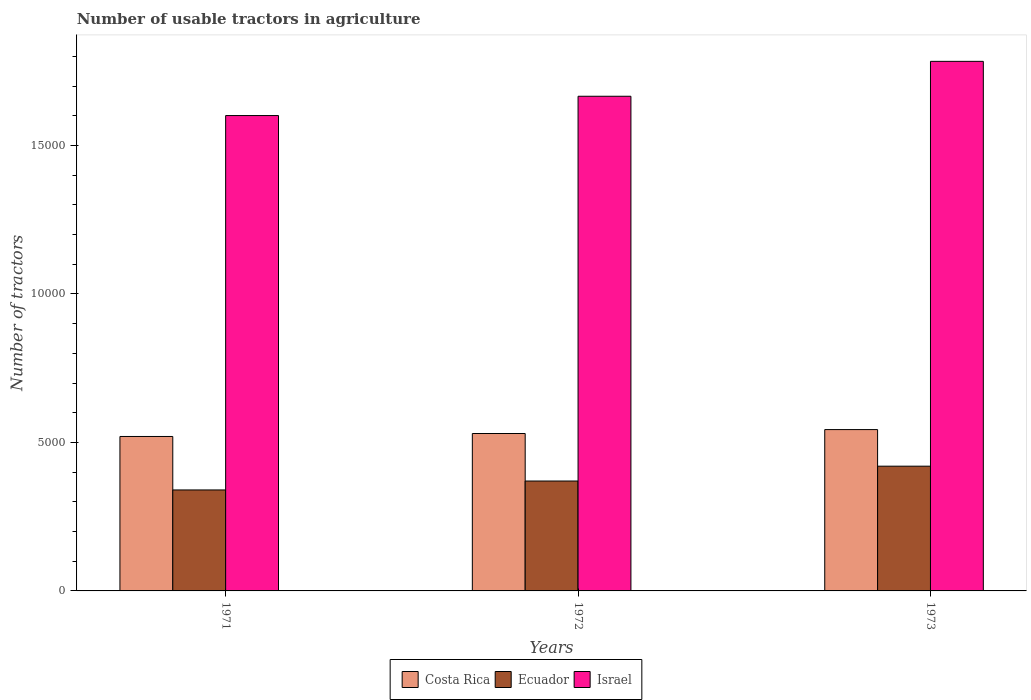How many different coloured bars are there?
Offer a terse response. 3. Are the number of bars on each tick of the X-axis equal?
Provide a succinct answer. Yes. What is the label of the 1st group of bars from the left?
Your answer should be very brief. 1971. In how many cases, is the number of bars for a given year not equal to the number of legend labels?
Give a very brief answer. 0. What is the number of usable tractors in agriculture in Costa Rica in 1972?
Make the answer very short. 5300. Across all years, what is the maximum number of usable tractors in agriculture in Israel?
Make the answer very short. 1.78e+04. Across all years, what is the minimum number of usable tractors in agriculture in Ecuador?
Ensure brevity in your answer.  3400. What is the total number of usable tractors in agriculture in Israel in the graph?
Offer a terse response. 5.05e+04. What is the difference between the number of usable tractors in agriculture in Israel in 1971 and that in 1973?
Your response must be concise. -1825. What is the difference between the number of usable tractors in agriculture in Israel in 1973 and the number of usable tractors in agriculture in Ecuador in 1972?
Give a very brief answer. 1.41e+04. What is the average number of usable tractors in agriculture in Ecuador per year?
Your answer should be very brief. 3766.67. In the year 1973, what is the difference between the number of usable tractors in agriculture in Costa Rica and number of usable tractors in agriculture in Ecuador?
Provide a succinct answer. 1232. What is the ratio of the number of usable tractors in agriculture in Costa Rica in 1972 to that in 1973?
Your response must be concise. 0.98. Is the difference between the number of usable tractors in agriculture in Costa Rica in 1971 and 1973 greater than the difference between the number of usable tractors in agriculture in Ecuador in 1971 and 1973?
Provide a succinct answer. Yes. What is the difference between the highest and the second highest number of usable tractors in agriculture in Israel?
Give a very brief answer. 1175. What is the difference between the highest and the lowest number of usable tractors in agriculture in Costa Rica?
Ensure brevity in your answer.  232. What does the 2nd bar from the left in 1972 represents?
Your response must be concise. Ecuador. Are all the bars in the graph horizontal?
Provide a succinct answer. No. Where does the legend appear in the graph?
Offer a terse response. Bottom center. How are the legend labels stacked?
Make the answer very short. Horizontal. What is the title of the graph?
Your answer should be very brief. Number of usable tractors in agriculture. Does "Singapore" appear as one of the legend labels in the graph?
Your response must be concise. No. What is the label or title of the X-axis?
Offer a terse response. Years. What is the label or title of the Y-axis?
Make the answer very short. Number of tractors. What is the Number of tractors in Costa Rica in 1971?
Ensure brevity in your answer.  5200. What is the Number of tractors of Ecuador in 1971?
Offer a terse response. 3400. What is the Number of tractors in Israel in 1971?
Offer a terse response. 1.60e+04. What is the Number of tractors in Costa Rica in 1972?
Your answer should be very brief. 5300. What is the Number of tractors of Ecuador in 1972?
Your answer should be very brief. 3700. What is the Number of tractors of Israel in 1972?
Offer a terse response. 1.67e+04. What is the Number of tractors of Costa Rica in 1973?
Provide a short and direct response. 5432. What is the Number of tractors in Ecuador in 1973?
Offer a very short reply. 4200. What is the Number of tractors in Israel in 1973?
Offer a very short reply. 1.78e+04. Across all years, what is the maximum Number of tractors in Costa Rica?
Keep it short and to the point. 5432. Across all years, what is the maximum Number of tractors of Ecuador?
Give a very brief answer. 4200. Across all years, what is the maximum Number of tractors in Israel?
Your response must be concise. 1.78e+04. Across all years, what is the minimum Number of tractors in Costa Rica?
Ensure brevity in your answer.  5200. Across all years, what is the minimum Number of tractors in Ecuador?
Provide a short and direct response. 3400. Across all years, what is the minimum Number of tractors in Israel?
Your response must be concise. 1.60e+04. What is the total Number of tractors of Costa Rica in the graph?
Ensure brevity in your answer.  1.59e+04. What is the total Number of tractors in Ecuador in the graph?
Provide a succinct answer. 1.13e+04. What is the total Number of tractors in Israel in the graph?
Offer a terse response. 5.05e+04. What is the difference between the Number of tractors of Costa Rica in 1971 and that in 1972?
Ensure brevity in your answer.  -100. What is the difference between the Number of tractors of Ecuador in 1971 and that in 1972?
Your response must be concise. -300. What is the difference between the Number of tractors in Israel in 1971 and that in 1972?
Your answer should be compact. -650. What is the difference between the Number of tractors in Costa Rica in 1971 and that in 1973?
Ensure brevity in your answer.  -232. What is the difference between the Number of tractors of Ecuador in 1971 and that in 1973?
Make the answer very short. -800. What is the difference between the Number of tractors of Israel in 1971 and that in 1973?
Your answer should be compact. -1825. What is the difference between the Number of tractors of Costa Rica in 1972 and that in 1973?
Your answer should be very brief. -132. What is the difference between the Number of tractors in Ecuador in 1972 and that in 1973?
Your response must be concise. -500. What is the difference between the Number of tractors in Israel in 1972 and that in 1973?
Your answer should be very brief. -1175. What is the difference between the Number of tractors of Costa Rica in 1971 and the Number of tractors of Ecuador in 1972?
Ensure brevity in your answer.  1500. What is the difference between the Number of tractors in Costa Rica in 1971 and the Number of tractors in Israel in 1972?
Your answer should be very brief. -1.15e+04. What is the difference between the Number of tractors of Ecuador in 1971 and the Number of tractors of Israel in 1972?
Offer a very short reply. -1.33e+04. What is the difference between the Number of tractors of Costa Rica in 1971 and the Number of tractors of Israel in 1973?
Provide a succinct answer. -1.26e+04. What is the difference between the Number of tractors of Ecuador in 1971 and the Number of tractors of Israel in 1973?
Ensure brevity in your answer.  -1.44e+04. What is the difference between the Number of tractors of Costa Rica in 1972 and the Number of tractors of Ecuador in 1973?
Your answer should be compact. 1100. What is the difference between the Number of tractors in Costa Rica in 1972 and the Number of tractors in Israel in 1973?
Give a very brief answer. -1.25e+04. What is the difference between the Number of tractors of Ecuador in 1972 and the Number of tractors of Israel in 1973?
Provide a short and direct response. -1.41e+04. What is the average Number of tractors of Costa Rica per year?
Your answer should be compact. 5310.67. What is the average Number of tractors of Ecuador per year?
Keep it short and to the point. 3766.67. What is the average Number of tractors of Israel per year?
Provide a short and direct response. 1.68e+04. In the year 1971, what is the difference between the Number of tractors of Costa Rica and Number of tractors of Ecuador?
Make the answer very short. 1800. In the year 1971, what is the difference between the Number of tractors of Costa Rica and Number of tractors of Israel?
Your response must be concise. -1.08e+04. In the year 1971, what is the difference between the Number of tractors of Ecuador and Number of tractors of Israel?
Your response must be concise. -1.26e+04. In the year 1972, what is the difference between the Number of tractors in Costa Rica and Number of tractors in Ecuador?
Make the answer very short. 1600. In the year 1972, what is the difference between the Number of tractors of Costa Rica and Number of tractors of Israel?
Provide a short and direct response. -1.14e+04. In the year 1972, what is the difference between the Number of tractors in Ecuador and Number of tractors in Israel?
Your answer should be very brief. -1.30e+04. In the year 1973, what is the difference between the Number of tractors in Costa Rica and Number of tractors in Ecuador?
Offer a terse response. 1232. In the year 1973, what is the difference between the Number of tractors in Costa Rica and Number of tractors in Israel?
Give a very brief answer. -1.24e+04. In the year 1973, what is the difference between the Number of tractors in Ecuador and Number of tractors in Israel?
Your response must be concise. -1.36e+04. What is the ratio of the Number of tractors in Costa Rica in 1971 to that in 1972?
Your answer should be compact. 0.98. What is the ratio of the Number of tractors in Ecuador in 1971 to that in 1972?
Give a very brief answer. 0.92. What is the ratio of the Number of tractors in Israel in 1971 to that in 1972?
Provide a succinct answer. 0.96. What is the ratio of the Number of tractors in Costa Rica in 1971 to that in 1973?
Offer a terse response. 0.96. What is the ratio of the Number of tractors in Ecuador in 1971 to that in 1973?
Your answer should be very brief. 0.81. What is the ratio of the Number of tractors of Israel in 1971 to that in 1973?
Offer a terse response. 0.9. What is the ratio of the Number of tractors of Costa Rica in 1972 to that in 1973?
Provide a short and direct response. 0.98. What is the ratio of the Number of tractors of Ecuador in 1972 to that in 1973?
Ensure brevity in your answer.  0.88. What is the ratio of the Number of tractors in Israel in 1972 to that in 1973?
Your answer should be very brief. 0.93. What is the difference between the highest and the second highest Number of tractors of Costa Rica?
Your response must be concise. 132. What is the difference between the highest and the second highest Number of tractors in Israel?
Provide a succinct answer. 1175. What is the difference between the highest and the lowest Number of tractors in Costa Rica?
Give a very brief answer. 232. What is the difference between the highest and the lowest Number of tractors of Ecuador?
Make the answer very short. 800. What is the difference between the highest and the lowest Number of tractors of Israel?
Your response must be concise. 1825. 